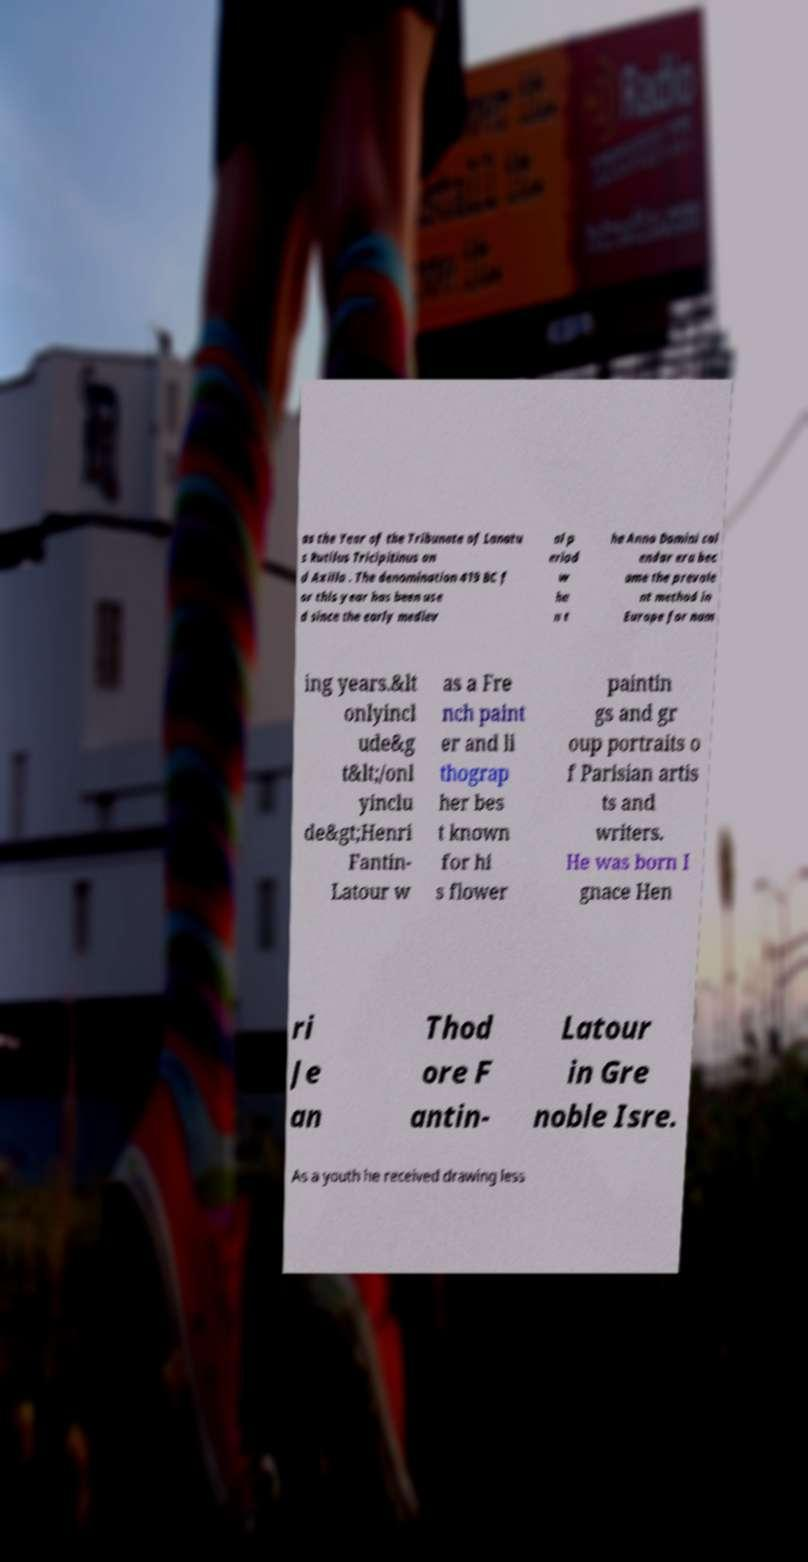What messages or text are displayed in this image? I need them in a readable, typed format. as the Year of the Tribunate of Lanatu s Rutilus Tricipitinus an d Axilla . The denomination 419 BC f or this year has been use d since the early mediev al p eriod w he n t he Anno Domini cal endar era bec ame the prevale nt method in Europe for nam ing years.&lt onlyincl ude&g t&lt;/onl yinclu de&gt;Henri Fantin- Latour w as a Fre nch paint er and li thograp her bes t known for hi s flower paintin gs and gr oup portraits o f Parisian artis ts and writers. He was born I gnace Hen ri Je an Thod ore F antin- Latour in Gre noble Isre. As a youth he received drawing less 